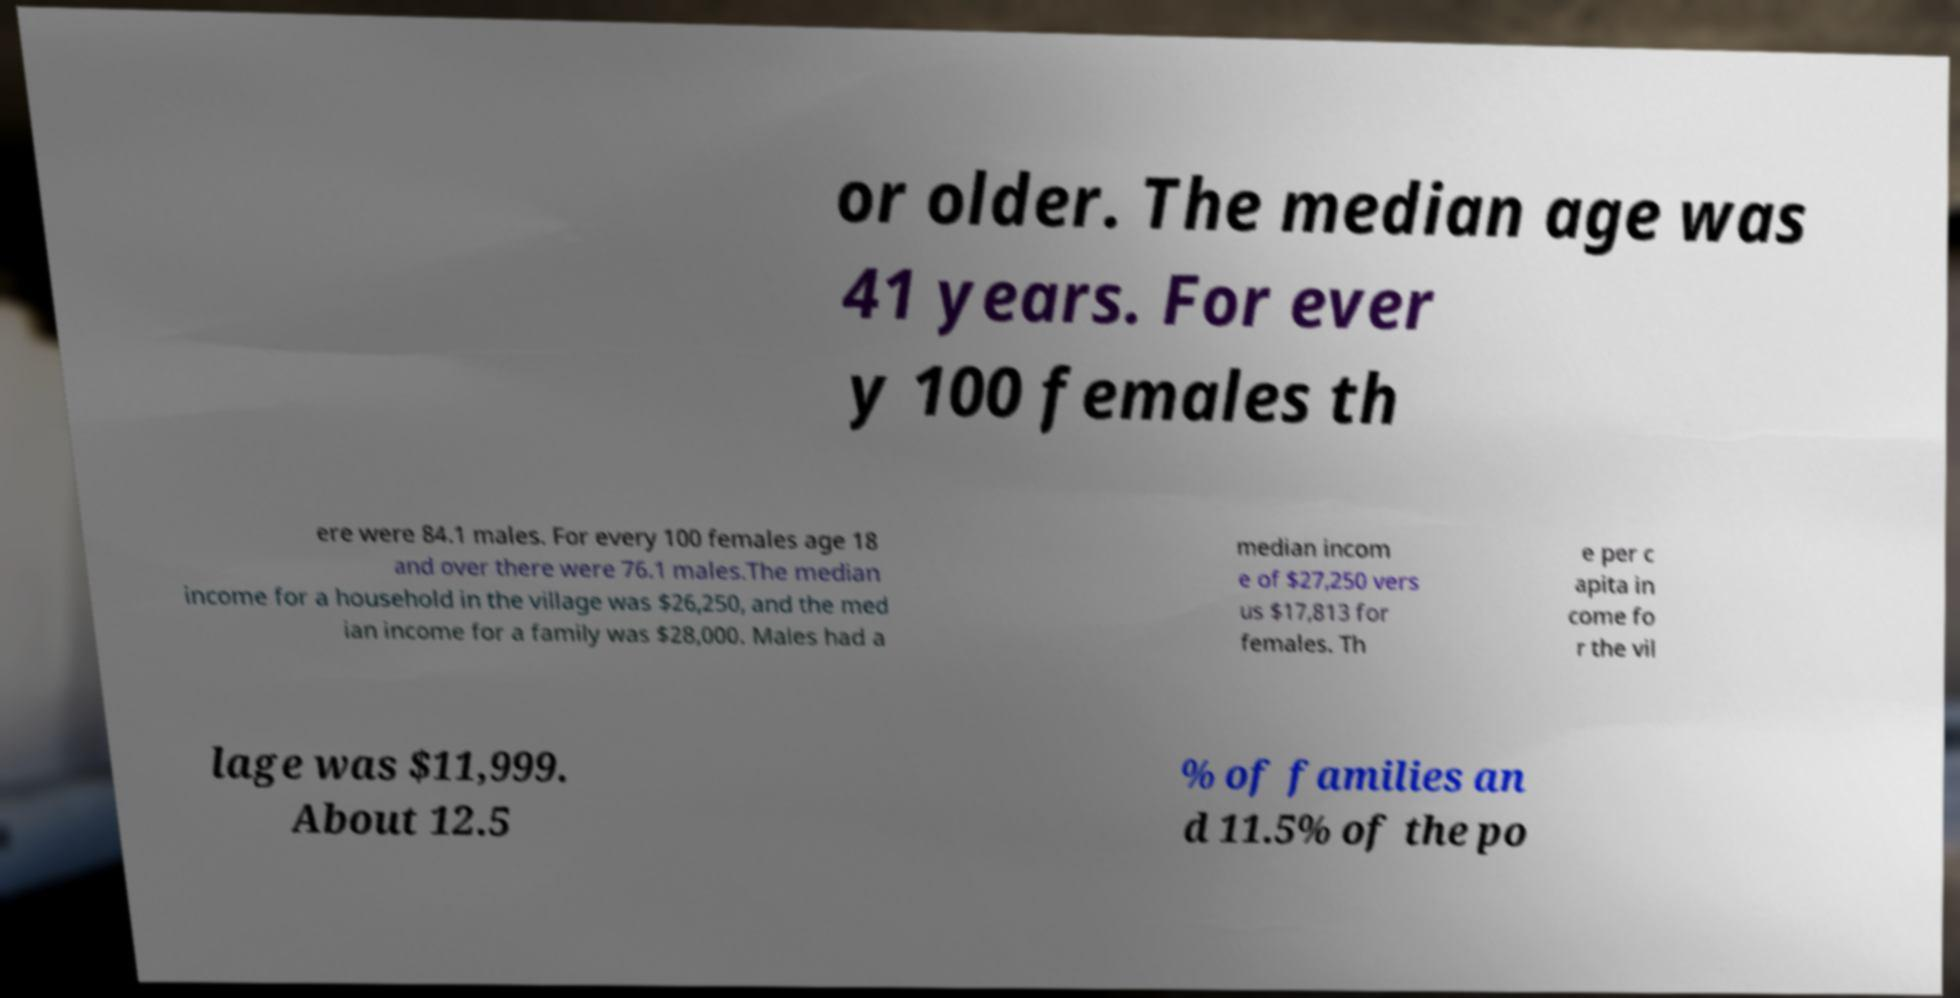There's text embedded in this image that I need extracted. Can you transcribe it verbatim? or older. The median age was 41 years. For ever y 100 females th ere were 84.1 males. For every 100 females age 18 and over there were 76.1 males.The median income for a household in the village was $26,250, and the med ian income for a family was $28,000. Males had a median incom e of $27,250 vers us $17,813 for females. Th e per c apita in come fo r the vil lage was $11,999. About 12.5 % of families an d 11.5% of the po 